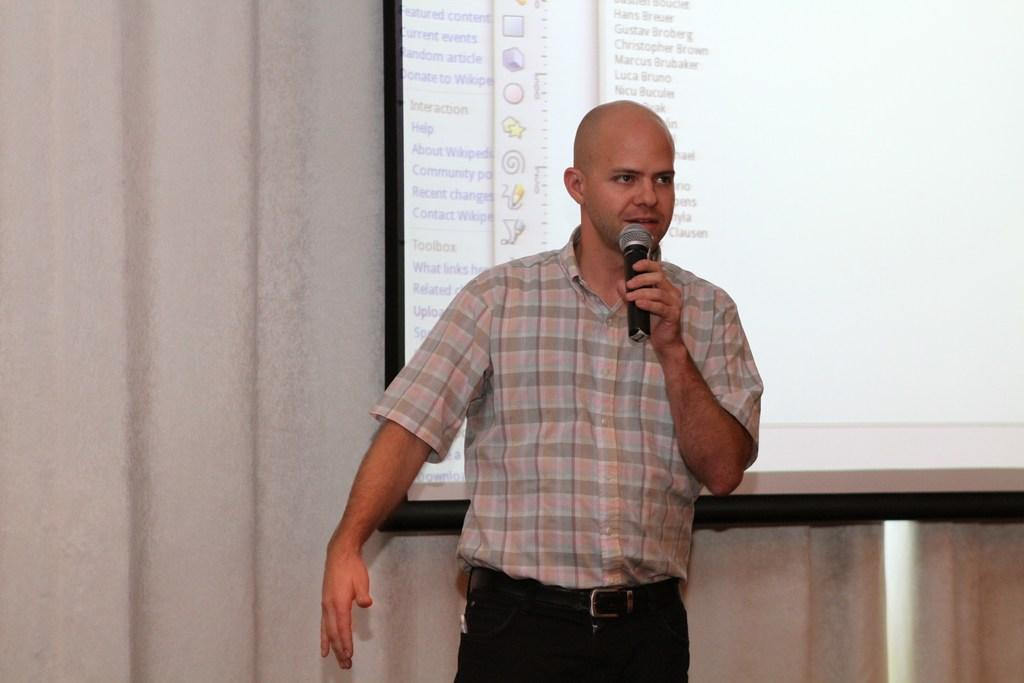What is the person in the image doing? The person is standing in the image and holding a microphone. What object is visible near the person? There is a projector screen visible in the image. What type of reward is the person holding in the image? There is no reward visible in the image; the person is holding a microphone. Can you see any wrens in the image? There are no wrens present in the image. 